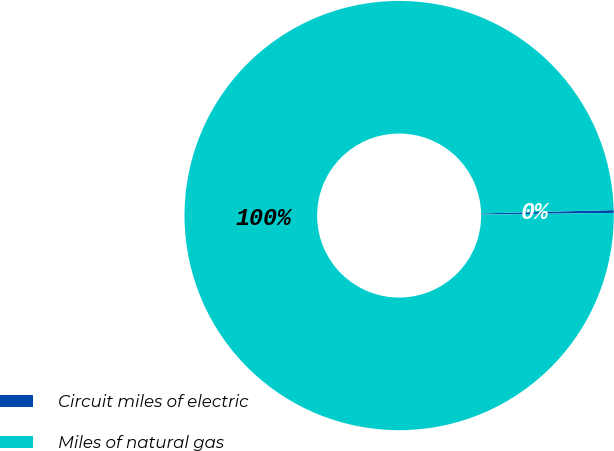<chart> <loc_0><loc_0><loc_500><loc_500><pie_chart><fcel>Circuit miles of electric<fcel>Miles of natural gas<nl><fcel>0.21%<fcel>99.79%<nl></chart> 